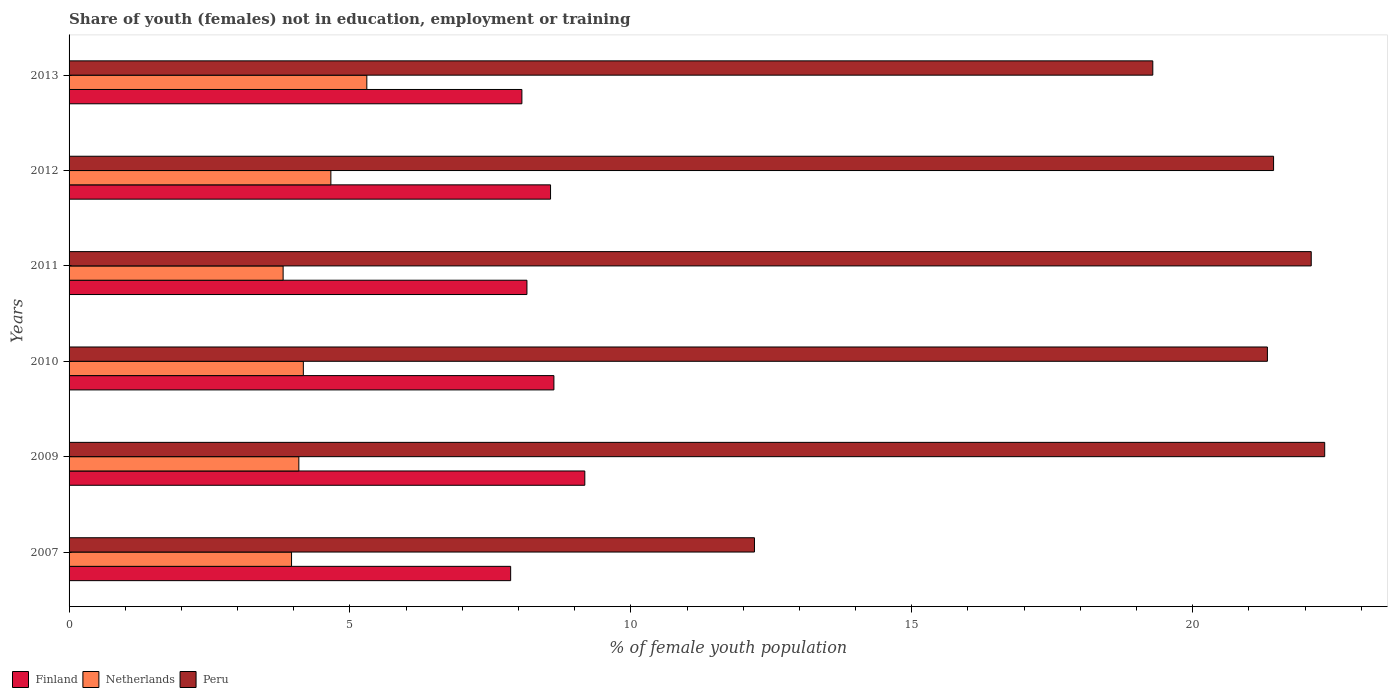How many groups of bars are there?
Provide a succinct answer. 6. Are the number of bars per tick equal to the number of legend labels?
Offer a terse response. Yes. Are the number of bars on each tick of the Y-axis equal?
Your response must be concise. Yes. What is the label of the 2nd group of bars from the top?
Offer a terse response. 2012. In how many cases, is the number of bars for a given year not equal to the number of legend labels?
Your answer should be compact. 0. What is the percentage of unemployed female population in in Finland in 2007?
Provide a short and direct response. 7.86. Across all years, what is the maximum percentage of unemployed female population in in Netherlands?
Provide a succinct answer. 5.3. Across all years, what is the minimum percentage of unemployed female population in in Netherlands?
Offer a very short reply. 3.81. In which year was the percentage of unemployed female population in in Netherlands maximum?
Give a very brief answer. 2013. What is the total percentage of unemployed female population in in Netherlands in the graph?
Your response must be concise. 25.99. What is the difference between the percentage of unemployed female population in in Finland in 2010 and that in 2011?
Provide a succinct answer. 0.48. What is the difference between the percentage of unemployed female population in in Netherlands in 2007 and the percentage of unemployed female population in in Finland in 2013?
Give a very brief answer. -4.1. What is the average percentage of unemployed female population in in Netherlands per year?
Your answer should be compact. 4.33. In the year 2011, what is the difference between the percentage of unemployed female population in in Netherlands and percentage of unemployed female population in in Peru?
Your answer should be very brief. -18.3. In how many years, is the percentage of unemployed female population in in Finland greater than 5 %?
Your answer should be compact. 6. What is the ratio of the percentage of unemployed female population in in Netherlands in 2010 to that in 2011?
Ensure brevity in your answer.  1.09. Is the percentage of unemployed female population in in Netherlands in 2009 less than that in 2012?
Your answer should be compact. Yes. Is the difference between the percentage of unemployed female population in in Netherlands in 2010 and 2011 greater than the difference between the percentage of unemployed female population in in Peru in 2010 and 2011?
Your answer should be very brief. Yes. What is the difference between the highest and the second highest percentage of unemployed female population in in Netherlands?
Ensure brevity in your answer.  0.64. What is the difference between the highest and the lowest percentage of unemployed female population in in Netherlands?
Provide a short and direct response. 1.49. In how many years, is the percentage of unemployed female population in in Finland greater than the average percentage of unemployed female population in in Finland taken over all years?
Provide a succinct answer. 3. How many bars are there?
Your answer should be very brief. 18. Are all the bars in the graph horizontal?
Your answer should be compact. Yes. How many years are there in the graph?
Make the answer very short. 6. Are the values on the major ticks of X-axis written in scientific E-notation?
Your response must be concise. No. Does the graph contain any zero values?
Keep it short and to the point. No. Does the graph contain grids?
Your answer should be compact. No. How are the legend labels stacked?
Offer a terse response. Horizontal. What is the title of the graph?
Provide a succinct answer. Share of youth (females) not in education, employment or training. What is the label or title of the X-axis?
Offer a very short reply. % of female youth population. What is the label or title of the Y-axis?
Your answer should be compact. Years. What is the % of female youth population in Finland in 2007?
Ensure brevity in your answer.  7.86. What is the % of female youth population in Netherlands in 2007?
Your answer should be very brief. 3.96. What is the % of female youth population of Peru in 2007?
Give a very brief answer. 12.2. What is the % of female youth population in Finland in 2009?
Your answer should be compact. 9.18. What is the % of female youth population of Netherlands in 2009?
Provide a succinct answer. 4.09. What is the % of female youth population in Peru in 2009?
Offer a terse response. 22.35. What is the % of female youth population in Finland in 2010?
Your response must be concise. 8.63. What is the % of female youth population of Netherlands in 2010?
Provide a succinct answer. 4.17. What is the % of female youth population of Peru in 2010?
Your response must be concise. 21.33. What is the % of female youth population of Finland in 2011?
Your response must be concise. 8.15. What is the % of female youth population of Netherlands in 2011?
Give a very brief answer. 3.81. What is the % of female youth population of Peru in 2011?
Keep it short and to the point. 22.11. What is the % of female youth population in Finland in 2012?
Provide a succinct answer. 8.57. What is the % of female youth population in Netherlands in 2012?
Make the answer very short. 4.66. What is the % of female youth population of Peru in 2012?
Keep it short and to the point. 21.44. What is the % of female youth population of Finland in 2013?
Offer a terse response. 8.06. What is the % of female youth population in Netherlands in 2013?
Keep it short and to the point. 5.3. What is the % of female youth population of Peru in 2013?
Offer a terse response. 19.29. Across all years, what is the maximum % of female youth population of Finland?
Offer a very short reply. 9.18. Across all years, what is the maximum % of female youth population in Netherlands?
Offer a terse response. 5.3. Across all years, what is the maximum % of female youth population of Peru?
Ensure brevity in your answer.  22.35. Across all years, what is the minimum % of female youth population of Finland?
Your answer should be very brief. 7.86. Across all years, what is the minimum % of female youth population of Netherlands?
Offer a terse response. 3.81. Across all years, what is the minimum % of female youth population in Peru?
Give a very brief answer. 12.2. What is the total % of female youth population in Finland in the graph?
Your answer should be compact. 50.45. What is the total % of female youth population in Netherlands in the graph?
Your answer should be compact. 25.99. What is the total % of female youth population in Peru in the graph?
Offer a very short reply. 118.72. What is the difference between the % of female youth population of Finland in 2007 and that in 2009?
Give a very brief answer. -1.32. What is the difference between the % of female youth population in Netherlands in 2007 and that in 2009?
Your answer should be very brief. -0.13. What is the difference between the % of female youth population in Peru in 2007 and that in 2009?
Your response must be concise. -10.15. What is the difference between the % of female youth population of Finland in 2007 and that in 2010?
Ensure brevity in your answer.  -0.77. What is the difference between the % of female youth population in Netherlands in 2007 and that in 2010?
Make the answer very short. -0.21. What is the difference between the % of female youth population in Peru in 2007 and that in 2010?
Provide a short and direct response. -9.13. What is the difference between the % of female youth population of Finland in 2007 and that in 2011?
Your answer should be very brief. -0.29. What is the difference between the % of female youth population of Netherlands in 2007 and that in 2011?
Ensure brevity in your answer.  0.15. What is the difference between the % of female youth population in Peru in 2007 and that in 2011?
Give a very brief answer. -9.91. What is the difference between the % of female youth population in Finland in 2007 and that in 2012?
Your response must be concise. -0.71. What is the difference between the % of female youth population in Peru in 2007 and that in 2012?
Make the answer very short. -9.24. What is the difference between the % of female youth population of Finland in 2007 and that in 2013?
Give a very brief answer. -0.2. What is the difference between the % of female youth population in Netherlands in 2007 and that in 2013?
Your response must be concise. -1.34. What is the difference between the % of female youth population of Peru in 2007 and that in 2013?
Ensure brevity in your answer.  -7.09. What is the difference between the % of female youth population in Finland in 2009 and that in 2010?
Your response must be concise. 0.55. What is the difference between the % of female youth population of Netherlands in 2009 and that in 2010?
Give a very brief answer. -0.08. What is the difference between the % of female youth population of Peru in 2009 and that in 2010?
Your response must be concise. 1.02. What is the difference between the % of female youth population of Netherlands in 2009 and that in 2011?
Offer a very short reply. 0.28. What is the difference between the % of female youth population in Peru in 2009 and that in 2011?
Provide a succinct answer. 0.24. What is the difference between the % of female youth population in Finland in 2009 and that in 2012?
Your response must be concise. 0.61. What is the difference between the % of female youth population in Netherlands in 2009 and that in 2012?
Offer a very short reply. -0.57. What is the difference between the % of female youth population of Peru in 2009 and that in 2012?
Your response must be concise. 0.91. What is the difference between the % of female youth population in Finland in 2009 and that in 2013?
Your response must be concise. 1.12. What is the difference between the % of female youth population of Netherlands in 2009 and that in 2013?
Make the answer very short. -1.21. What is the difference between the % of female youth population of Peru in 2009 and that in 2013?
Give a very brief answer. 3.06. What is the difference between the % of female youth population in Finland in 2010 and that in 2011?
Your answer should be compact. 0.48. What is the difference between the % of female youth population of Netherlands in 2010 and that in 2011?
Keep it short and to the point. 0.36. What is the difference between the % of female youth population in Peru in 2010 and that in 2011?
Make the answer very short. -0.78. What is the difference between the % of female youth population of Netherlands in 2010 and that in 2012?
Make the answer very short. -0.49. What is the difference between the % of female youth population in Peru in 2010 and that in 2012?
Give a very brief answer. -0.11. What is the difference between the % of female youth population in Finland in 2010 and that in 2013?
Your answer should be compact. 0.57. What is the difference between the % of female youth population of Netherlands in 2010 and that in 2013?
Give a very brief answer. -1.13. What is the difference between the % of female youth population of Peru in 2010 and that in 2013?
Ensure brevity in your answer.  2.04. What is the difference between the % of female youth population of Finland in 2011 and that in 2012?
Your answer should be very brief. -0.42. What is the difference between the % of female youth population of Netherlands in 2011 and that in 2012?
Your answer should be very brief. -0.85. What is the difference between the % of female youth population in Peru in 2011 and that in 2012?
Offer a very short reply. 0.67. What is the difference between the % of female youth population in Finland in 2011 and that in 2013?
Make the answer very short. 0.09. What is the difference between the % of female youth population in Netherlands in 2011 and that in 2013?
Offer a terse response. -1.49. What is the difference between the % of female youth population in Peru in 2011 and that in 2013?
Your answer should be very brief. 2.82. What is the difference between the % of female youth population in Finland in 2012 and that in 2013?
Make the answer very short. 0.51. What is the difference between the % of female youth population of Netherlands in 2012 and that in 2013?
Offer a terse response. -0.64. What is the difference between the % of female youth population of Peru in 2012 and that in 2013?
Ensure brevity in your answer.  2.15. What is the difference between the % of female youth population in Finland in 2007 and the % of female youth population in Netherlands in 2009?
Provide a short and direct response. 3.77. What is the difference between the % of female youth population in Finland in 2007 and the % of female youth population in Peru in 2009?
Offer a very short reply. -14.49. What is the difference between the % of female youth population in Netherlands in 2007 and the % of female youth population in Peru in 2009?
Your response must be concise. -18.39. What is the difference between the % of female youth population of Finland in 2007 and the % of female youth population of Netherlands in 2010?
Offer a very short reply. 3.69. What is the difference between the % of female youth population of Finland in 2007 and the % of female youth population of Peru in 2010?
Provide a short and direct response. -13.47. What is the difference between the % of female youth population in Netherlands in 2007 and the % of female youth population in Peru in 2010?
Your answer should be very brief. -17.37. What is the difference between the % of female youth population of Finland in 2007 and the % of female youth population of Netherlands in 2011?
Make the answer very short. 4.05. What is the difference between the % of female youth population of Finland in 2007 and the % of female youth population of Peru in 2011?
Make the answer very short. -14.25. What is the difference between the % of female youth population in Netherlands in 2007 and the % of female youth population in Peru in 2011?
Give a very brief answer. -18.15. What is the difference between the % of female youth population of Finland in 2007 and the % of female youth population of Netherlands in 2012?
Ensure brevity in your answer.  3.2. What is the difference between the % of female youth population in Finland in 2007 and the % of female youth population in Peru in 2012?
Make the answer very short. -13.58. What is the difference between the % of female youth population of Netherlands in 2007 and the % of female youth population of Peru in 2012?
Ensure brevity in your answer.  -17.48. What is the difference between the % of female youth population in Finland in 2007 and the % of female youth population in Netherlands in 2013?
Make the answer very short. 2.56. What is the difference between the % of female youth population of Finland in 2007 and the % of female youth population of Peru in 2013?
Make the answer very short. -11.43. What is the difference between the % of female youth population of Netherlands in 2007 and the % of female youth population of Peru in 2013?
Provide a short and direct response. -15.33. What is the difference between the % of female youth population in Finland in 2009 and the % of female youth population in Netherlands in 2010?
Provide a short and direct response. 5.01. What is the difference between the % of female youth population of Finland in 2009 and the % of female youth population of Peru in 2010?
Provide a short and direct response. -12.15. What is the difference between the % of female youth population in Netherlands in 2009 and the % of female youth population in Peru in 2010?
Provide a succinct answer. -17.24. What is the difference between the % of female youth population of Finland in 2009 and the % of female youth population of Netherlands in 2011?
Offer a very short reply. 5.37. What is the difference between the % of female youth population of Finland in 2009 and the % of female youth population of Peru in 2011?
Your answer should be compact. -12.93. What is the difference between the % of female youth population in Netherlands in 2009 and the % of female youth population in Peru in 2011?
Offer a very short reply. -18.02. What is the difference between the % of female youth population of Finland in 2009 and the % of female youth population of Netherlands in 2012?
Make the answer very short. 4.52. What is the difference between the % of female youth population of Finland in 2009 and the % of female youth population of Peru in 2012?
Provide a short and direct response. -12.26. What is the difference between the % of female youth population of Netherlands in 2009 and the % of female youth population of Peru in 2012?
Your response must be concise. -17.35. What is the difference between the % of female youth population in Finland in 2009 and the % of female youth population in Netherlands in 2013?
Keep it short and to the point. 3.88. What is the difference between the % of female youth population in Finland in 2009 and the % of female youth population in Peru in 2013?
Offer a terse response. -10.11. What is the difference between the % of female youth population in Netherlands in 2009 and the % of female youth population in Peru in 2013?
Your response must be concise. -15.2. What is the difference between the % of female youth population of Finland in 2010 and the % of female youth population of Netherlands in 2011?
Make the answer very short. 4.82. What is the difference between the % of female youth population in Finland in 2010 and the % of female youth population in Peru in 2011?
Your answer should be compact. -13.48. What is the difference between the % of female youth population of Netherlands in 2010 and the % of female youth population of Peru in 2011?
Your answer should be very brief. -17.94. What is the difference between the % of female youth population in Finland in 2010 and the % of female youth population in Netherlands in 2012?
Offer a very short reply. 3.97. What is the difference between the % of female youth population of Finland in 2010 and the % of female youth population of Peru in 2012?
Give a very brief answer. -12.81. What is the difference between the % of female youth population in Netherlands in 2010 and the % of female youth population in Peru in 2012?
Your response must be concise. -17.27. What is the difference between the % of female youth population of Finland in 2010 and the % of female youth population of Netherlands in 2013?
Make the answer very short. 3.33. What is the difference between the % of female youth population in Finland in 2010 and the % of female youth population in Peru in 2013?
Keep it short and to the point. -10.66. What is the difference between the % of female youth population of Netherlands in 2010 and the % of female youth population of Peru in 2013?
Your answer should be very brief. -15.12. What is the difference between the % of female youth population in Finland in 2011 and the % of female youth population in Netherlands in 2012?
Ensure brevity in your answer.  3.49. What is the difference between the % of female youth population in Finland in 2011 and the % of female youth population in Peru in 2012?
Make the answer very short. -13.29. What is the difference between the % of female youth population in Netherlands in 2011 and the % of female youth population in Peru in 2012?
Keep it short and to the point. -17.63. What is the difference between the % of female youth population of Finland in 2011 and the % of female youth population of Netherlands in 2013?
Offer a terse response. 2.85. What is the difference between the % of female youth population in Finland in 2011 and the % of female youth population in Peru in 2013?
Your answer should be very brief. -11.14. What is the difference between the % of female youth population of Netherlands in 2011 and the % of female youth population of Peru in 2013?
Your answer should be very brief. -15.48. What is the difference between the % of female youth population of Finland in 2012 and the % of female youth population of Netherlands in 2013?
Your response must be concise. 3.27. What is the difference between the % of female youth population in Finland in 2012 and the % of female youth population in Peru in 2013?
Your answer should be very brief. -10.72. What is the difference between the % of female youth population of Netherlands in 2012 and the % of female youth population of Peru in 2013?
Ensure brevity in your answer.  -14.63. What is the average % of female youth population in Finland per year?
Provide a short and direct response. 8.41. What is the average % of female youth population of Netherlands per year?
Your answer should be compact. 4.33. What is the average % of female youth population of Peru per year?
Make the answer very short. 19.79. In the year 2007, what is the difference between the % of female youth population of Finland and % of female youth population of Peru?
Your response must be concise. -4.34. In the year 2007, what is the difference between the % of female youth population in Netherlands and % of female youth population in Peru?
Offer a terse response. -8.24. In the year 2009, what is the difference between the % of female youth population in Finland and % of female youth population in Netherlands?
Your response must be concise. 5.09. In the year 2009, what is the difference between the % of female youth population in Finland and % of female youth population in Peru?
Provide a succinct answer. -13.17. In the year 2009, what is the difference between the % of female youth population in Netherlands and % of female youth population in Peru?
Your response must be concise. -18.26. In the year 2010, what is the difference between the % of female youth population in Finland and % of female youth population in Netherlands?
Your response must be concise. 4.46. In the year 2010, what is the difference between the % of female youth population in Netherlands and % of female youth population in Peru?
Provide a succinct answer. -17.16. In the year 2011, what is the difference between the % of female youth population in Finland and % of female youth population in Netherlands?
Ensure brevity in your answer.  4.34. In the year 2011, what is the difference between the % of female youth population of Finland and % of female youth population of Peru?
Ensure brevity in your answer.  -13.96. In the year 2011, what is the difference between the % of female youth population in Netherlands and % of female youth population in Peru?
Provide a succinct answer. -18.3. In the year 2012, what is the difference between the % of female youth population of Finland and % of female youth population of Netherlands?
Provide a short and direct response. 3.91. In the year 2012, what is the difference between the % of female youth population in Finland and % of female youth population in Peru?
Your response must be concise. -12.87. In the year 2012, what is the difference between the % of female youth population of Netherlands and % of female youth population of Peru?
Keep it short and to the point. -16.78. In the year 2013, what is the difference between the % of female youth population in Finland and % of female youth population in Netherlands?
Provide a succinct answer. 2.76. In the year 2013, what is the difference between the % of female youth population in Finland and % of female youth population in Peru?
Make the answer very short. -11.23. In the year 2013, what is the difference between the % of female youth population in Netherlands and % of female youth population in Peru?
Provide a succinct answer. -13.99. What is the ratio of the % of female youth population of Finland in 2007 to that in 2009?
Provide a short and direct response. 0.86. What is the ratio of the % of female youth population of Netherlands in 2007 to that in 2009?
Give a very brief answer. 0.97. What is the ratio of the % of female youth population of Peru in 2007 to that in 2009?
Your answer should be compact. 0.55. What is the ratio of the % of female youth population of Finland in 2007 to that in 2010?
Your answer should be compact. 0.91. What is the ratio of the % of female youth population in Netherlands in 2007 to that in 2010?
Your response must be concise. 0.95. What is the ratio of the % of female youth population in Peru in 2007 to that in 2010?
Keep it short and to the point. 0.57. What is the ratio of the % of female youth population in Finland in 2007 to that in 2011?
Keep it short and to the point. 0.96. What is the ratio of the % of female youth population in Netherlands in 2007 to that in 2011?
Provide a short and direct response. 1.04. What is the ratio of the % of female youth population in Peru in 2007 to that in 2011?
Your response must be concise. 0.55. What is the ratio of the % of female youth population of Finland in 2007 to that in 2012?
Your answer should be very brief. 0.92. What is the ratio of the % of female youth population of Netherlands in 2007 to that in 2012?
Make the answer very short. 0.85. What is the ratio of the % of female youth population in Peru in 2007 to that in 2012?
Your answer should be compact. 0.57. What is the ratio of the % of female youth population in Finland in 2007 to that in 2013?
Offer a terse response. 0.98. What is the ratio of the % of female youth population in Netherlands in 2007 to that in 2013?
Your answer should be very brief. 0.75. What is the ratio of the % of female youth population of Peru in 2007 to that in 2013?
Your response must be concise. 0.63. What is the ratio of the % of female youth population of Finland in 2009 to that in 2010?
Provide a succinct answer. 1.06. What is the ratio of the % of female youth population in Netherlands in 2009 to that in 2010?
Provide a short and direct response. 0.98. What is the ratio of the % of female youth population in Peru in 2009 to that in 2010?
Your response must be concise. 1.05. What is the ratio of the % of female youth population in Finland in 2009 to that in 2011?
Your answer should be very brief. 1.13. What is the ratio of the % of female youth population in Netherlands in 2009 to that in 2011?
Ensure brevity in your answer.  1.07. What is the ratio of the % of female youth population in Peru in 2009 to that in 2011?
Provide a short and direct response. 1.01. What is the ratio of the % of female youth population of Finland in 2009 to that in 2012?
Ensure brevity in your answer.  1.07. What is the ratio of the % of female youth population of Netherlands in 2009 to that in 2012?
Give a very brief answer. 0.88. What is the ratio of the % of female youth population in Peru in 2009 to that in 2012?
Your answer should be very brief. 1.04. What is the ratio of the % of female youth population of Finland in 2009 to that in 2013?
Your answer should be very brief. 1.14. What is the ratio of the % of female youth population in Netherlands in 2009 to that in 2013?
Give a very brief answer. 0.77. What is the ratio of the % of female youth population of Peru in 2009 to that in 2013?
Provide a succinct answer. 1.16. What is the ratio of the % of female youth population of Finland in 2010 to that in 2011?
Your answer should be very brief. 1.06. What is the ratio of the % of female youth population of Netherlands in 2010 to that in 2011?
Give a very brief answer. 1.09. What is the ratio of the % of female youth population of Peru in 2010 to that in 2011?
Provide a succinct answer. 0.96. What is the ratio of the % of female youth population in Netherlands in 2010 to that in 2012?
Provide a short and direct response. 0.89. What is the ratio of the % of female youth population of Finland in 2010 to that in 2013?
Your answer should be very brief. 1.07. What is the ratio of the % of female youth population of Netherlands in 2010 to that in 2013?
Provide a succinct answer. 0.79. What is the ratio of the % of female youth population of Peru in 2010 to that in 2013?
Make the answer very short. 1.11. What is the ratio of the % of female youth population in Finland in 2011 to that in 2012?
Your answer should be compact. 0.95. What is the ratio of the % of female youth population of Netherlands in 2011 to that in 2012?
Your answer should be compact. 0.82. What is the ratio of the % of female youth population of Peru in 2011 to that in 2012?
Ensure brevity in your answer.  1.03. What is the ratio of the % of female youth population in Finland in 2011 to that in 2013?
Provide a short and direct response. 1.01. What is the ratio of the % of female youth population of Netherlands in 2011 to that in 2013?
Ensure brevity in your answer.  0.72. What is the ratio of the % of female youth population in Peru in 2011 to that in 2013?
Give a very brief answer. 1.15. What is the ratio of the % of female youth population of Finland in 2012 to that in 2013?
Offer a very short reply. 1.06. What is the ratio of the % of female youth population of Netherlands in 2012 to that in 2013?
Give a very brief answer. 0.88. What is the ratio of the % of female youth population in Peru in 2012 to that in 2013?
Keep it short and to the point. 1.11. What is the difference between the highest and the second highest % of female youth population in Finland?
Keep it short and to the point. 0.55. What is the difference between the highest and the second highest % of female youth population of Netherlands?
Your answer should be compact. 0.64. What is the difference between the highest and the second highest % of female youth population of Peru?
Give a very brief answer. 0.24. What is the difference between the highest and the lowest % of female youth population in Finland?
Your answer should be very brief. 1.32. What is the difference between the highest and the lowest % of female youth population of Netherlands?
Offer a very short reply. 1.49. What is the difference between the highest and the lowest % of female youth population of Peru?
Your answer should be compact. 10.15. 